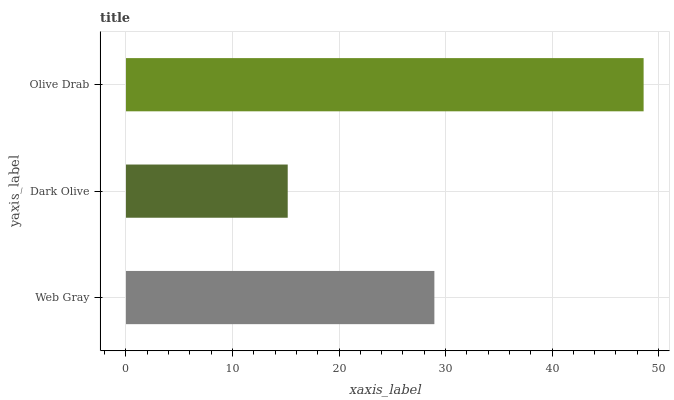Is Dark Olive the minimum?
Answer yes or no. Yes. Is Olive Drab the maximum?
Answer yes or no. Yes. Is Olive Drab the minimum?
Answer yes or no. No. Is Dark Olive the maximum?
Answer yes or no. No. Is Olive Drab greater than Dark Olive?
Answer yes or no. Yes. Is Dark Olive less than Olive Drab?
Answer yes or no. Yes. Is Dark Olive greater than Olive Drab?
Answer yes or no. No. Is Olive Drab less than Dark Olive?
Answer yes or no. No. Is Web Gray the high median?
Answer yes or no. Yes. Is Web Gray the low median?
Answer yes or no. Yes. Is Olive Drab the high median?
Answer yes or no. No. Is Dark Olive the low median?
Answer yes or no. No. 